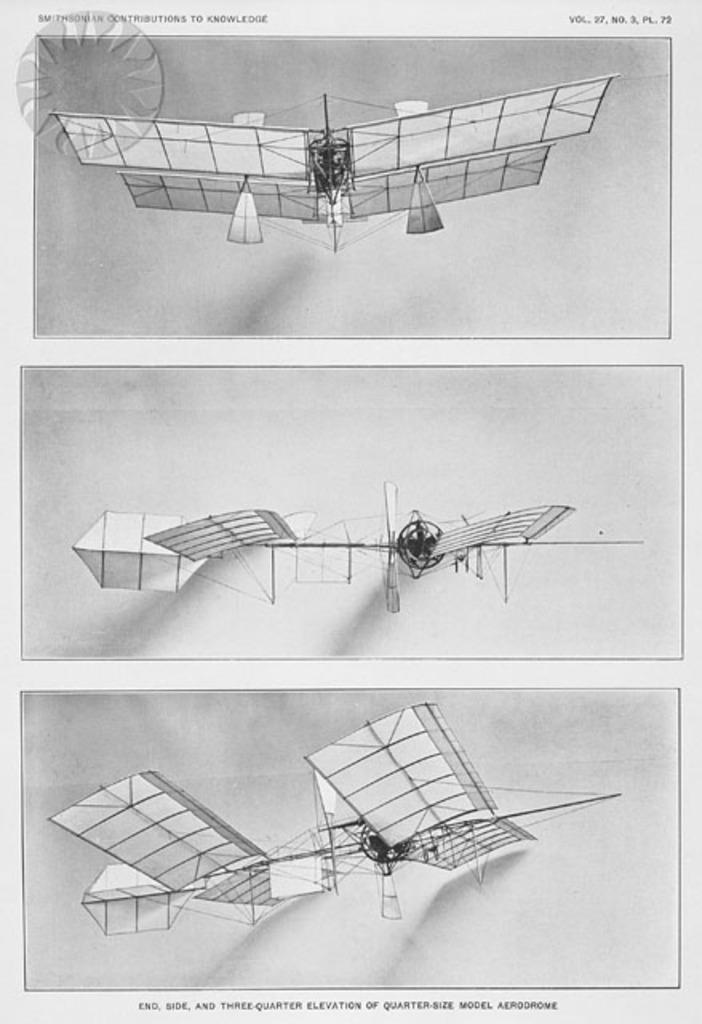<image>
Describe the image concisely. An old drawing of a human powered airplane published in Smithsonian is shown. 